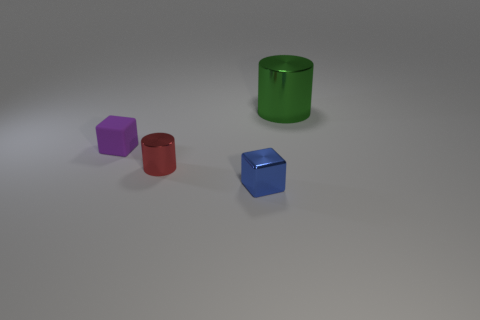There is a tiny thing behind the red metal cylinder; what is its material?
Your answer should be very brief. Rubber. The red shiny thing that is the same shape as the big green object is what size?
Ensure brevity in your answer.  Small. Is the number of things behind the small red metal thing less than the number of objects?
Offer a terse response. Yes. Are any small purple cubes visible?
Your response must be concise. Yes. There is another object that is the same shape as the tiny red thing; what color is it?
Give a very brief answer. Green. Do the tiny metallic object that is behind the tiny blue thing and the metallic cube have the same color?
Your response must be concise. No. Do the purple matte cube and the blue block have the same size?
Provide a short and direct response. Yes. The tiny blue thing that is made of the same material as the green cylinder is what shape?
Your answer should be compact. Cube. How many other objects are the same shape as the blue thing?
Your answer should be very brief. 1. There is a object in front of the cylinder in front of the metal cylinder that is to the right of the small red shiny thing; what shape is it?
Keep it short and to the point. Cube. 